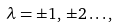Convert formula to latex. <formula><loc_0><loc_0><loc_500><loc_500>\lambda = \pm 1 , \, \pm 2 \dots ,</formula> 